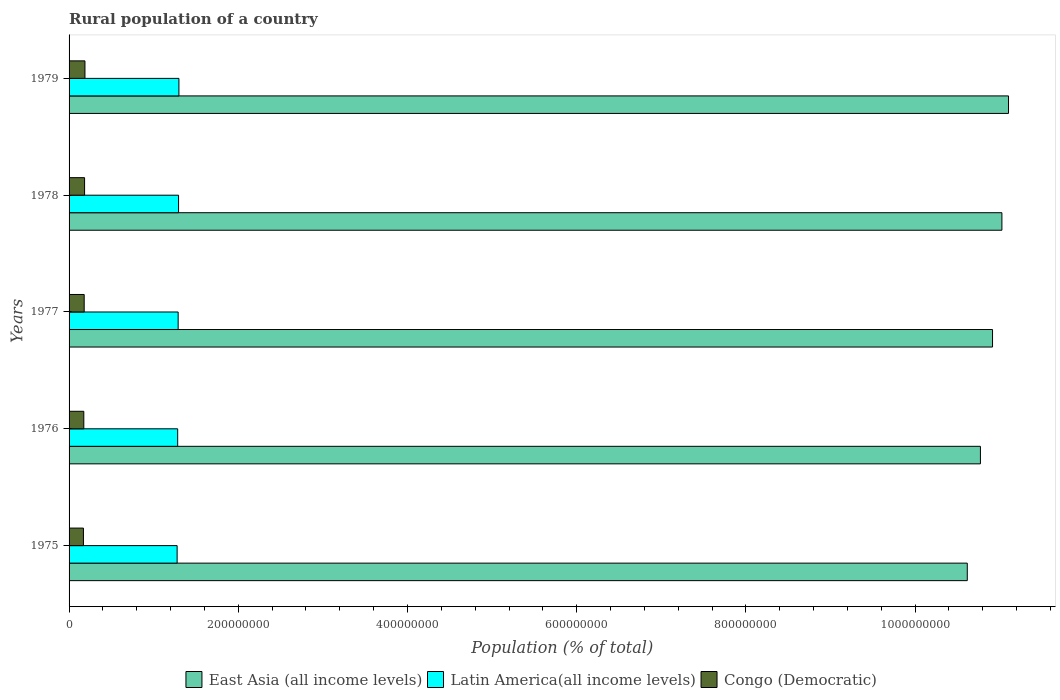How many groups of bars are there?
Provide a succinct answer. 5. Are the number of bars on each tick of the Y-axis equal?
Ensure brevity in your answer.  Yes. How many bars are there on the 5th tick from the top?
Give a very brief answer. 3. How many bars are there on the 1st tick from the bottom?
Ensure brevity in your answer.  3. What is the label of the 2nd group of bars from the top?
Offer a very short reply. 1978. In how many cases, is the number of bars for a given year not equal to the number of legend labels?
Offer a terse response. 0. What is the rural population in Latin America(all income levels) in 1978?
Give a very brief answer. 1.29e+08. Across all years, what is the maximum rural population in East Asia (all income levels)?
Offer a terse response. 1.11e+09. Across all years, what is the minimum rural population in East Asia (all income levels)?
Provide a short and direct response. 1.06e+09. In which year was the rural population in East Asia (all income levels) maximum?
Offer a very short reply. 1979. In which year was the rural population in Latin America(all income levels) minimum?
Make the answer very short. 1975. What is the total rural population in Latin America(all income levels) in the graph?
Your response must be concise. 6.44e+08. What is the difference between the rural population in Latin America(all income levels) in 1978 and that in 1979?
Offer a very short reply. -4.29e+05. What is the difference between the rural population in East Asia (all income levels) in 1978 and the rural population in Congo (Democratic) in 1975?
Your answer should be very brief. 1.09e+09. What is the average rural population in Congo (Democratic) per year?
Offer a terse response. 1.79e+07. In the year 1978, what is the difference between the rural population in Latin America(all income levels) and rural population in Congo (Democratic)?
Your answer should be compact. 1.11e+08. What is the ratio of the rural population in Latin America(all income levels) in 1976 to that in 1977?
Offer a terse response. 1. Is the difference between the rural population in Latin America(all income levels) in 1976 and 1979 greater than the difference between the rural population in Congo (Democratic) in 1976 and 1979?
Keep it short and to the point. No. What is the difference between the highest and the second highest rural population in Latin America(all income levels)?
Provide a succinct answer. 4.29e+05. What is the difference between the highest and the lowest rural population in Latin America(all income levels)?
Your answer should be very brief. 2.13e+06. Is the sum of the rural population in Congo (Democratic) in 1975 and 1977 greater than the maximum rural population in East Asia (all income levels) across all years?
Provide a succinct answer. No. What does the 2nd bar from the top in 1975 represents?
Provide a succinct answer. Latin America(all income levels). What does the 1st bar from the bottom in 1975 represents?
Your answer should be compact. East Asia (all income levels). Is it the case that in every year, the sum of the rural population in Latin America(all income levels) and rural population in Congo (Democratic) is greater than the rural population in East Asia (all income levels)?
Provide a short and direct response. No. Are all the bars in the graph horizontal?
Give a very brief answer. Yes. What is the difference between two consecutive major ticks on the X-axis?
Make the answer very short. 2.00e+08. Does the graph contain any zero values?
Your answer should be very brief. No. Does the graph contain grids?
Keep it short and to the point. No. Where does the legend appear in the graph?
Your answer should be compact. Bottom center. What is the title of the graph?
Provide a succinct answer. Rural population of a country. What is the label or title of the X-axis?
Your response must be concise. Population (% of total). What is the Population (% of total) in East Asia (all income levels) in 1975?
Offer a very short reply. 1.06e+09. What is the Population (% of total) of Latin America(all income levels) in 1975?
Provide a succinct answer. 1.28e+08. What is the Population (% of total) of Congo (Democratic) in 1975?
Provide a succinct answer. 1.70e+07. What is the Population (% of total) of East Asia (all income levels) in 1976?
Ensure brevity in your answer.  1.08e+09. What is the Population (% of total) of Latin America(all income levels) in 1976?
Keep it short and to the point. 1.28e+08. What is the Population (% of total) in Congo (Democratic) in 1976?
Your answer should be very brief. 1.74e+07. What is the Population (% of total) of East Asia (all income levels) in 1977?
Offer a terse response. 1.09e+09. What is the Population (% of total) in Latin America(all income levels) in 1977?
Make the answer very short. 1.29e+08. What is the Population (% of total) in Congo (Democratic) in 1977?
Offer a very short reply. 1.79e+07. What is the Population (% of total) in East Asia (all income levels) in 1978?
Provide a short and direct response. 1.10e+09. What is the Population (% of total) of Latin America(all income levels) in 1978?
Offer a terse response. 1.29e+08. What is the Population (% of total) of Congo (Democratic) in 1978?
Provide a succinct answer. 1.83e+07. What is the Population (% of total) in East Asia (all income levels) in 1979?
Your response must be concise. 1.11e+09. What is the Population (% of total) in Latin America(all income levels) in 1979?
Your response must be concise. 1.30e+08. What is the Population (% of total) in Congo (Democratic) in 1979?
Offer a very short reply. 1.88e+07. Across all years, what is the maximum Population (% of total) in East Asia (all income levels)?
Offer a terse response. 1.11e+09. Across all years, what is the maximum Population (% of total) of Latin America(all income levels)?
Keep it short and to the point. 1.30e+08. Across all years, what is the maximum Population (% of total) of Congo (Democratic)?
Your answer should be compact. 1.88e+07. Across all years, what is the minimum Population (% of total) of East Asia (all income levels)?
Offer a terse response. 1.06e+09. Across all years, what is the minimum Population (% of total) of Latin America(all income levels)?
Provide a succinct answer. 1.28e+08. Across all years, what is the minimum Population (% of total) of Congo (Democratic)?
Your answer should be compact. 1.70e+07. What is the total Population (% of total) of East Asia (all income levels) in the graph?
Give a very brief answer. 5.44e+09. What is the total Population (% of total) of Latin America(all income levels) in the graph?
Ensure brevity in your answer.  6.44e+08. What is the total Population (% of total) of Congo (Democratic) in the graph?
Your answer should be compact. 8.94e+07. What is the difference between the Population (% of total) in East Asia (all income levels) in 1975 and that in 1976?
Provide a short and direct response. -1.55e+07. What is the difference between the Population (% of total) in Latin America(all income levels) in 1975 and that in 1976?
Provide a short and direct response. -6.47e+05. What is the difference between the Population (% of total) of Congo (Democratic) in 1975 and that in 1976?
Offer a terse response. -4.27e+05. What is the difference between the Population (% of total) in East Asia (all income levels) in 1975 and that in 1977?
Offer a very short reply. -2.98e+07. What is the difference between the Population (% of total) of Latin America(all income levels) in 1975 and that in 1977?
Your answer should be compact. -1.21e+06. What is the difference between the Population (% of total) in Congo (Democratic) in 1975 and that in 1977?
Offer a terse response. -8.74e+05. What is the difference between the Population (% of total) of East Asia (all income levels) in 1975 and that in 1978?
Keep it short and to the point. -4.09e+07. What is the difference between the Population (% of total) in Latin America(all income levels) in 1975 and that in 1978?
Provide a short and direct response. -1.70e+06. What is the difference between the Population (% of total) of Congo (Democratic) in 1975 and that in 1978?
Offer a terse response. -1.33e+06. What is the difference between the Population (% of total) in East Asia (all income levels) in 1975 and that in 1979?
Provide a short and direct response. -4.87e+07. What is the difference between the Population (% of total) of Latin America(all income levels) in 1975 and that in 1979?
Your response must be concise. -2.13e+06. What is the difference between the Population (% of total) of Congo (Democratic) in 1975 and that in 1979?
Give a very brief answer. -1.79e+06. What is the difference between the Population (% of total) in East Asia (all income levels) in 1976 and that in 1977?
Keep it short and to the point. -1.43e+07. What is the difference between the Population (% of total) of Latin America(all income levels) in 1976 and that in 1977?
Provide a succinct answer. -5.62e+05. What is the difference between the Population (% of total) in Congo (Democratic) in 1976 and that in 1977?
Offer a terse response. -4.47e+05. What is the difference between the Population (% of total) of East Asia (all income levels) in 1976 and that in 1978?
Your answer should be compact. -2.54e+07. What is the difference between the Population (% of total) in Latin America(all income levels) in 1976 and that in 1978?
Your answer should be compact. -1.05e+06. What is the difference between the Population (% of total) in Congo (Democratic) in 1976 and that in 1978?
Make the answer very short. -9.04e+05. What is the difference between the Population (% of total) of East Asia (all income levels) in 1976 and that in 1979?
Your answer should be very brief. -3.32e+07. What is the difference between the Population (% of total) of Latin America(all income levels) in 1976 and that in 1979?
Give a very brief answer. -1.48e+06. What is the difference between the Population (% of total) of Congo (Democratic) in 1976 and that in 1979?
Ensure brevity in your answer.  -1.36e+06. What is the difference between the Population (% of total) of East Asia (all income levels) in 1977 and that in 1978?
Offer a very short reply. -1.11e+07. What is the difference between the Population (% of total) in Latin America(all income levels) in 1977 and that in 1978?
Provide a succinct answer. -4.88e+05. What is the difference between the Population (% of total) in Congo (Democratic) in 1977 and that in 1978?
Give a very brief answer. -4.57e+05. What is the difference between the Population (% of total) in East Asia (all income levels) in 1977 and that in 1979?
Your answer should be very brief. -1.89e+07. What is the difference between the Population (% of total) in Latin America(all income levels) in 1977 and that in 1979?
Make the answer very short. -9.17e+05. What is the difference between the Population (% of total) of Congo (Democratic) in 1977 and that in 1979?
Give a very brief answer. -9.13e+05. What is the difference between the Population (% of total) of East Asia (all income levels) in 1978 and that in 1979?
Your response must be concise. -7.83e+06. What is the difference between the Population (% of total) in Latin America(all income levels) in 1978 and that in 1979?
Offer a terse response. -4.29e+05. What is the difference between the Population (% of total) in Congo (Democratic) in 1978 and that in 1979?
Keep it short and to the point. -4.56e+05. What is the difference between the Population (% of total) of East Asia (all income levels) in 1975 and the Population (% of total) of Latin America(all income levels) in 1976?
Offer a terse response. 9.33e+08. What is the difference between the Population (% of total) of East Asia (all income levels) in 1975 and the Population (% of total) of Congo (Democratic) in 1976?
Keep it short and to the point. 1.04e+09. What is the difference between the Population (% of total) of Latin America(all income levels) in 1975 and the Population (% of total) of Congo (Democratic) in 1976?
Make the answer very short. 1.10e+08. What is the difference between the Population (% of total) of East Asia (all income levels) in 1975 and the Population (% of total) of Latin America(all income levels) in 1977?
Your response must be concise. 9.33e+08. What is the difference between the Population (% of total) in East Asia (all income levels) in 1975 and the Population (% of total) in Congo (Democratic) in 1977?
Give a very brief answer. 1.04e+09. What is the difference between the Population (% of total) in Latin America(all income levels) in 1975 and the Population (% of total) in Congo (Democratic) in 1977?
Make the answer very short. 1.10e+08. What is the difference between the Population (% of total) in East Asia (all income levels) in 1975 and the Population (% of total) in Latin America(all income levels) in 1978?
Offer a terse response. 9.32e+08. What is the difference between the Population (% of total) in East Asia (all income levels) in 1975 and the Population (% of total) in Congo (Democratic) in 1978?
Your answer should be compact. 1.04e+09. What is the difference between the Population (% of total) of Latin America(all income levels) in 1975 and the Population (% of total) of Congo (Democratic) in 1978?
Offer a terse response. 1.09e+08. What is the difference between the Population (% of total) in East Asia (all income levels) in 1975 and the Population (% of total) in Latin America(all income levels) in 1979?
Offer a terse response. 9.32e+08. What is the difference between the Population (% of total) of East Asia (all income levels) in 1975 and the Population (% of total) of Congo (Democratic) in 1979?
Keep it short and to the point. 1.04e+09. What is the difference between the Population (% of total) in Latin America(all income levels) in 1975 and the Population (% of total) in Congo (Democratic) in 1979?
Your answer should be very brief. 1.09e+08. What is the difference between the Population (% of total) of East Asia (all income levels) in 1976 and the Population (% of total) of Latin America(all income levels) in 1977?
Keep it short and to the point. 9.48e+08. What is the difference between the Population (% of total) of East Asia (all income levels) in 1976 and the Population (% of total) of Congo (Democratic) in 1977?
Make the answer very short. 1.06e+09. What is the difference between the Population (% of total) in Latin America(all income levels) in 1976 and the Population (% of total) in Congo (Democratic) in 1977?
Keep it short and to the point. 1.11e+08. What is the difference between the Population (% of total) of East Asia (all income levels) in 1976 and the Population (% of total) of Latin America(all income levels) in 1978?
Provide a succinct answer. 9.48e+08. What is the difference between the Population (% of total) in East Asia (all income levels) in 1976 and the Population (% of total) in Congo (Democratic) in 1978?
Offer a terse response. 1.06e+09. What is the difference between the Population (% of total) of Latin America(all income levels) in 1976 and the Population (% of total) of Congo (Democratic) in 1978?
Your answer should be very brief. 1.10e+08. What is the difference between the Population (% of total) in East Asia (all income levels) in 1976 and the Population (% of total) in Latin America(all income levels) in 1979?
Make the answer very short. 9.47e+08. What is the difference between the Population (% of total) of East Asia (all income levels) in 1976 and the Population (% of total) of Congo (Democratic) in 1979?
Keep it short and to the point. 1.06e+09. What is the difference between the Population (% of total) in Latin America(all income levels) in 1976 and the Population (% of total) in Congo (Democratic) in 1979?
Provide a succinct answer. 1.10e+08. What is the difference between the Population (% of total) of East Asia (all income levels) in 1977 and the Population (% of total) of Latin America(all income levels) in 1978?
Offer a terse response. 9.62e+08. What is the difference between the Population (% of total) in East Asia (all income levels) in 1977 and the Population (% of total) in Congo (Democratic) in 1978?
Ensure brevity in your answer.  1.07e+09. What is the difference between the Population (% of total) of Latin America(all income levels) in 1977 and the Population (% of total) of Congo (Democratic) in 1978?
Offer a terse response. 1.11e+08. What is the difference between the Population (% of total) in East Asia (all income levels) in 1977 and the Population (% of total) in Latin America(all income levels) in 1979?
Keep it short and to the point. 9.62e+08. What is the difference between the Population (% of total) of East Asia (all income levels) in 1977 and the Population (% of total) of Congo (Democratic) in 1979?
Ensure brevity in your answer.  1.07e+09. What is the difference between the Population (% of total) in Latin America(all income levels) in 1977 and the Population (% of total) in Congo (Democratic) in 1979?
Keep it short and to the point. 1.10e+08. What is the difference between the Population (% of total) in East Asia (all income levels) in 1978 and the Population (% of total) in Latin America(all income levels) in 1979?
Your answer should be very brief. 9.73e+08. What is the difference between the Population (% of total) of East Asia (all income levels) in 1978 and the Population (% of total) of Congo (Democratic) in 1979?
Keep it short and to the point. 1.08e+09. What is the difference between the Population (% of total) in Latin America(all income levels) in 1978 and the Population (% of total) in Congo (Democratic) in 1979?
Offer a very short reply. 1.11e+08. What is the average Population (% of total) of East Asia (all income levels) per year?
Provide a succinct answer. 1.09e+09. What is the average Population (% of total) of Latin America(all income levels) per year?
Offer a very short reply. 1.29e+08. What is the average Population (% of total) in Congo (Democratic) per year?
Ensure brevity in your answer.  1.79e+07. In the year 1975, what is the difference between the Population (% of total) of East Asia (all income levels) and Population (% of total) of Latin America(all income levels)?
Your answer should be very brief. 9.34e+08. In the year 1975, what is the difference between the Population (% of total) in East Asia (all income levels) and Population (% of total) in Congo (Democratic)?
Ensure brevity in your answer.  1.04e+09. In the year 1975, what is the difference between the Population (% of total) of Latin America(all income levels) and Population (% of total) of Congo (Democratic)?
Offer a very short reply. 1.11e+08. In the year 1976, what is the difference between the Population (% of total) in East Asia (all income levels) and Population (% of total) in Latin America(all income levels)?
Your response must be concise. 9.49e+08. In the year 1976, what is the difference between the Population (% of total) of East Asia (all income levels) and Population (% of total) of Congo (Democratic)?
Offer a terse response. 1.06e+09. In the year 1976, what is the difference between the Population (% of total) of Latin America(all income levels) and Population (% of total) of Congo (Democratic)?
Offer a terse response. 1.11e+08. In the year 1977, what is the difference between the Population (% of total) of East Asia (all income levels) and Population (% of total) of Latin America(all income levels)?
Offer a very short reply. 9.63e+08. In the year 1977, what is the difference between the Population (% of total) in East Asia (all income levels) and Population (% of total) in Congo (Democratic)?
Provide a short and direct response. 1.07e+09. In the year 1977, what is the difference between the Population (% of total) in Latin America(all income levels) and Population (% of total) in Congo (Democratic)?
Ensure brevity in your answer.  1.11e+08. In the year 1978, what is the difference between the Population (% of total) in East Asia (all income levels) and Population (% of total) in Latin America(all income levels)?
Your response must be concise. 9.73e+08. In the year 1978, what is the difference between the Population (% of total) in East Asia (all income levels) and Population (% of total) in Congo (Democratic)?
Give a very brief answer. 1.08e+09. In the year 1978, what is the difference between the Population (% of total) of Latin America(all income levels) and Population (% of total) of Congo (Democratic)?
Provide a short and direct response. 1.11e+08. In the year 1979, what is the difference between the Population (% of total) in East Asia (all income levels) and Population (% of total) in Latin America(all income levels)?
Make the answer very short. 9.81e+08. In the year 1979, what is the difference between the Population (% of total) in East Asia (all income levels) and Population (% of total) in Congo (Democratic)?
Keep it short and to the point. 1.09e+09. In the year 1979, what is the difference between the Population (% of total) in Latin America(all income levels) and Population (% of total) in Congo (Democratic)?
Provide a succinct answer. 1.11e+08. What is the ratio of the Population (% of total) of East Asia (all income levels) in 1975 to that in 1976?
Your answer should be very brief. 0.99. What is the ratio of the Population (% of total) in Latin America(all income levels) in 1975 to that in 1976?
Your answer should be compact. 0.99. What is the ratio of the Population (% of total) in Congo (Democratic) in 1975 to that in 1976?
Provide a short and direct response. 0.98. What is the ratio of the Population (% of total) in East Asia (all income levels) in 1975 to that in 1977?
Offer a terse response. 0.97. What is the ratio of the Population (% of total) in Latin America(all income levels) in 1975 to that in 1977?
Your response must be concise. 0.99. What is the ratio of the Population (% of total) in Congo (Democratic) in 1975 to that in 1977?
Ensure brevity in your answer.  0.95. What is the ratio of the Population (% of total) of East Asia (all income levels) in 1975 to that in 1978?
Your response must be concise. 0.96. What is the ratio of the Population (% of total) of Latin America(all income levels) in 1975 to that in 1978?
Make the answer very short. 0.99. What is the ratio of the Population (% of total) of Congo (Democratic) in 1975 to that in 1978?
Your answer should be very brief. 0.93. What is the ratio of the Population (% of total) of East Asia (all income levels) in 1975 to that in 1979?
Make the answer very short. 0.96. What is the ratio of the Population (% of total) in Latin America(all income levels) in 1975 to that in 1979?
Your answer should be compact. 0.98. What is the ratio of the Population (% of total) in Congo (Democratic) in 1975 to that in 1979?
Make the answer very short. 0.9. What is the ratio of the Population (% of total) of East Asia (all income levels) in 1976 to that in 1977?
Your response must be concise. 0.99. What is the ratio of the Population (% of total) in Latin America(all income levels) in 1976 to that in 1978?
Offer a terse response. 0.99. What is the ratio of the Population (% of total) in Congo (Democratic) in 1976 to that in 1978?
Ensure brevity in your answer.  0.95. What is the ratio of the Population (% of total) in East Asia (all income levels) in 1976 to that in 1979?
Provide a succinct answer. 0.97. What is the ratio of the Population (% of total) of Congo (Democratic) in 1976 to that in 1979?
Keep it short and to the point. 0.93. What is the ratio of the Population (% of total) of East Asia (all income levels) in 1977 to that in 1978?
Your response must be concise. 0.99. What is the ratio of the Population (% of total) in Congo (Democratic) in 1977 to that in 1978?
Provide a short and direct response. 0.97. What is the ratio of the Population (% of total) in East Asia (all income levels) in 1977 to that in 1979?
Make the answer very short. 0.98. What is the ratio of the Population (% of total) of Congo (Democratic) in 1977 to that in 1979?
Ensure brevity in your answer.  0.95. What is the ratio of the Population (% of total) of Latin America(all income levels) in 1978 to that in 1979?
Ensure brevity in your answer.  1. What is the ratio of the Population (% of total) in Congo (Democratic) in 1978 to that in 1979?
Provide a succinct answer. 0.98. What is the difference between the highest and the second highest Population (% of total) of East Asia (all income levels)?
Provide a succinct answer. 7.83e+06. What is the difference between the highest and the second highest Population (% of total) in Latin America(all income levels)?
Provide a short and direct response. 4.29e+05. What is the difference between the highest and the second highest Population (% of total) in Congo (Democratic)?
Your answer should be very brief. 4.56e+05. What is the difference between the highest and the lowest Population (% of total) in East Asia (all income levels)?
Keep it short and to the point. 4.87e+07. What is the difference between the highest and the lowest Population (% of total) of Latin America(all income levels)?
Your response must be concise. 2.13e+06. What is the difference between the highest and the lowest Population (% of total) of Congo (Democratic)?
Your answer should be very brief. 1.79e+06. 